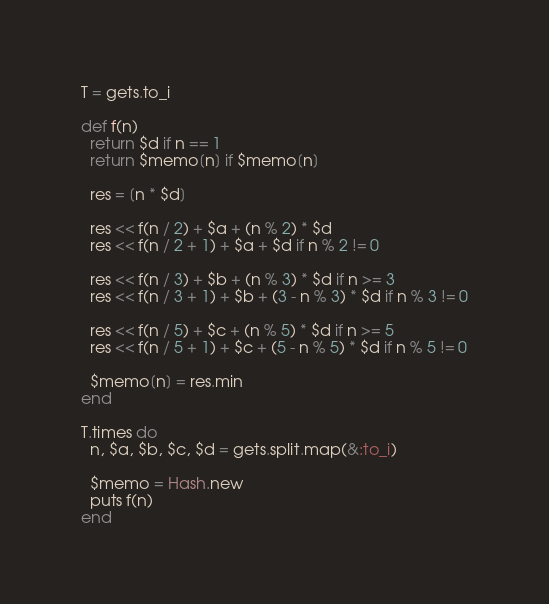Convert code to text. <code><loc_0><loc_0><loc_500><loc_500><_Ruby_>T = gets.to_i

def f(n)
  return $d if n == 1
  return $memo[n] if $memo[n]

  res = [n * $d]

  res << f(n / 2) + $a + (n % 2) * $d
  res << f(n / 2 + 1) + $a + $d if n % 2 != 0

  res << f(n / 3) + $b + (n % 3) * $d if n >= 3
  res << f(n / 3 + 1) + $b + (3 - n % 3) * $d if n % 3 != 0

  res << f(n / 5) + $c + (n % 5) * $d if n >= 5
  res << f(n / 5 + 1) + $c + (5 - n % 5) * $d if n % 5 != 0

  $memo[n] = res.min
end

T.times do
  n, $a, $b, $c, $d = gets.split.map(&:to_i)

  $memo = Hash.new
  puts f(n)
end
</code> 